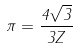Convert formula to latex. <formula><loc_0><loc_0><loc_500><loc_500>\pi = \frac { 4 \sqrt { 3 } } { 3 Z }</formula> 